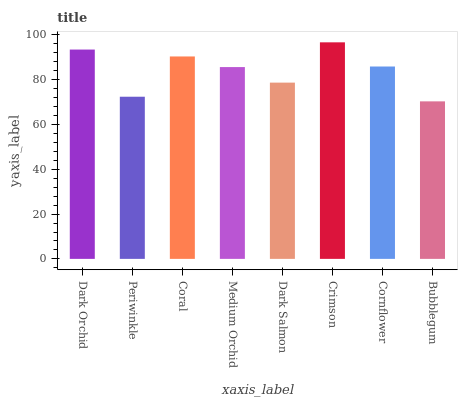Is Bubblegum the minimum?
Answer yes or no. Yes. Is Crimson the maximum?
Answer yes or no. Yes. Is Periwinkle the minimum?
Answer yes or no. No. Is Periwinkle the maximum?
Answer yes or no. No. Is Dark Orchid greater than Periwinkle?
Answer yes or no. Yes. Is Periwinkle less than Dark Orchid?
Answer yes or no. Yes. Is Periwinkle greater than Dark Orchid?
Answer yes or no. No. Is Dark Orchid less than Periwinkle?
Answer yes or no. No. Is Cornflower the high median?
Answer yes or no. Yes. Is Medium Orchid the low median?
Answer yes or no. Yes. Is Periwinkle the high median?
Answer yes or no. No. Is Dark Orchid the low median?
Answer yes or no. No. 